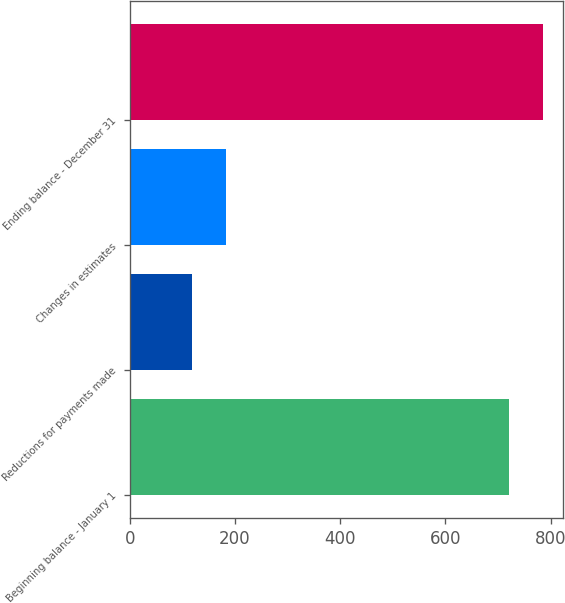<chart> <loc_0><loc_0><loc_500><loc_500><bar_chart><fcel>Beginning balance - January 1<fcel>Reductions for payments made<fcel>Changes in estimates<fcel>Ending balance - December 31<nl><fcel>721<fcel>118<fcel>182<fcel>785<nl></chart> 